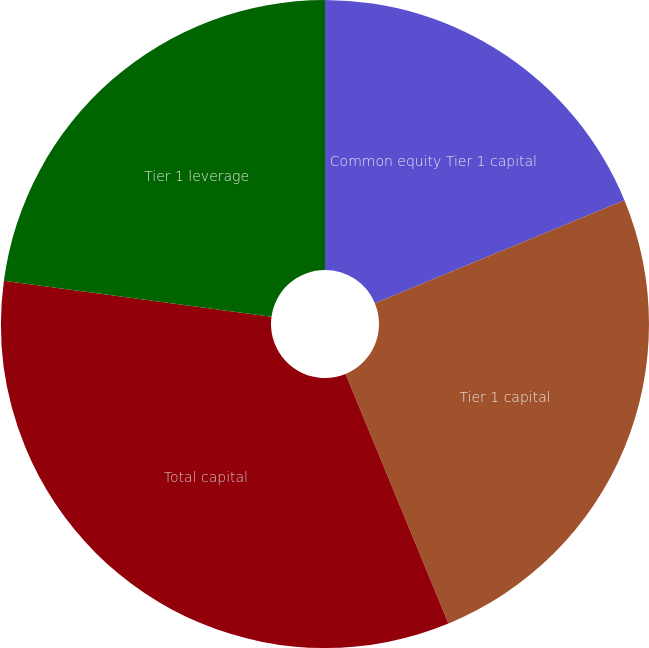Convert chart. <chart><loc_0><loc_0><loc_500><loc_500><pie_chart><fcel>Common equity Tier 1 capital<fcel>Tier 1 capital<fcel>Total capital<fcel>Tier 1 leverage<nl><fcel>18.76%<fcel>25.02%<fcel>33.35%<fcel>22.87%<nl></chart> 